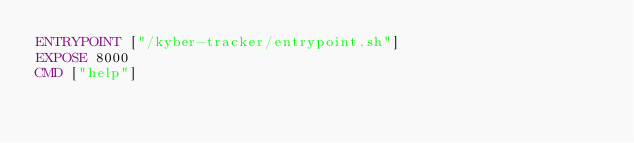Convert code to text. <code><loc_0><loc_0><loc_500><loc_500><_Dockerfile_>ENTRYPOINT ["/kyber-tracker/entrypoint.sh"]
EXPOSE 8000
CMD ["help"]
</code> 